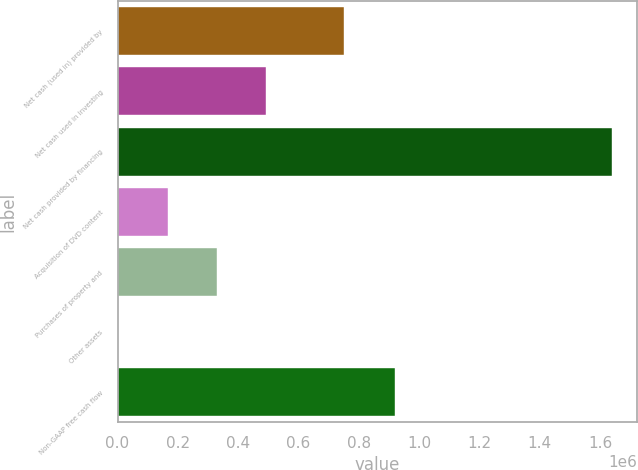Convert chart to OTSL. <chart><loc_0><loc_0><loc_500><loc_500><bar_chart><fcel>Net cash (used in) provided by<fcel>Net cash used in investing<fcel>Net cash provided by financing<fcel>Acquisition of DVD content<fcel>Purchases of property and<fcel>Other assets<fcel>Non-GAAP free cash flow<nl><fcel>749439<fcel>493422<fcel>1.64028e+06<fcel>165748<fcel>329585<fcel>1912<fcel>920557<nl></chart> 